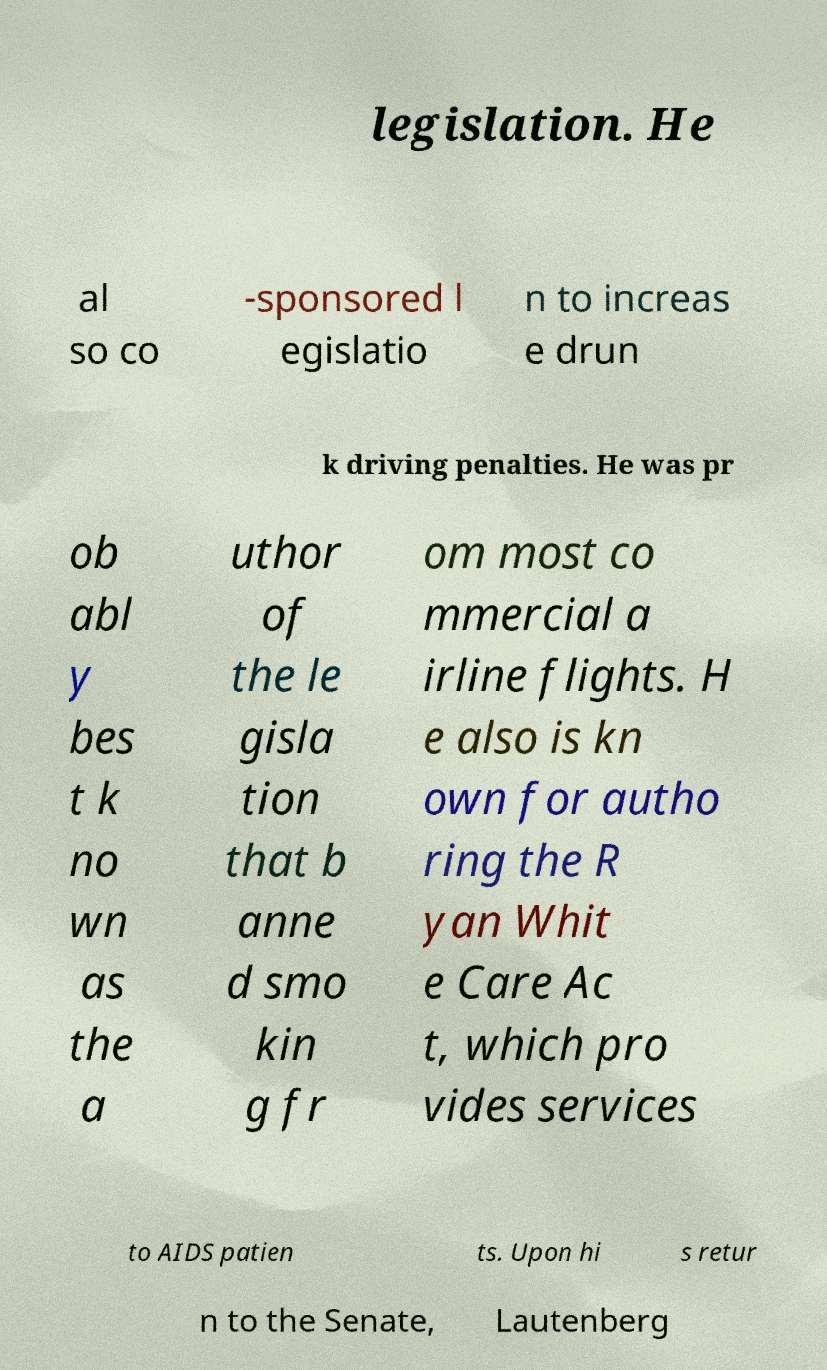Please read and relay the text visible in this image. What does it say? legislation. He al so co -sponsored l egislatio n to increas e drun k driving penalties. He was pr ob abl y bes t k no wn as the a uthor of the le gisla tion that b anne d smo kin g fr om most co mmercial a irline flights. H e also is kn own for autho ring the R yan Whit e Care Ac t, which pro vides services to AIDS patien ts. Upon hi s retur n to the Senate, Lautenberg 